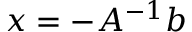<formula> <loc_0><loc_0><loc_500><loc_500>x = - A ^ { - 1 } b</formula> 